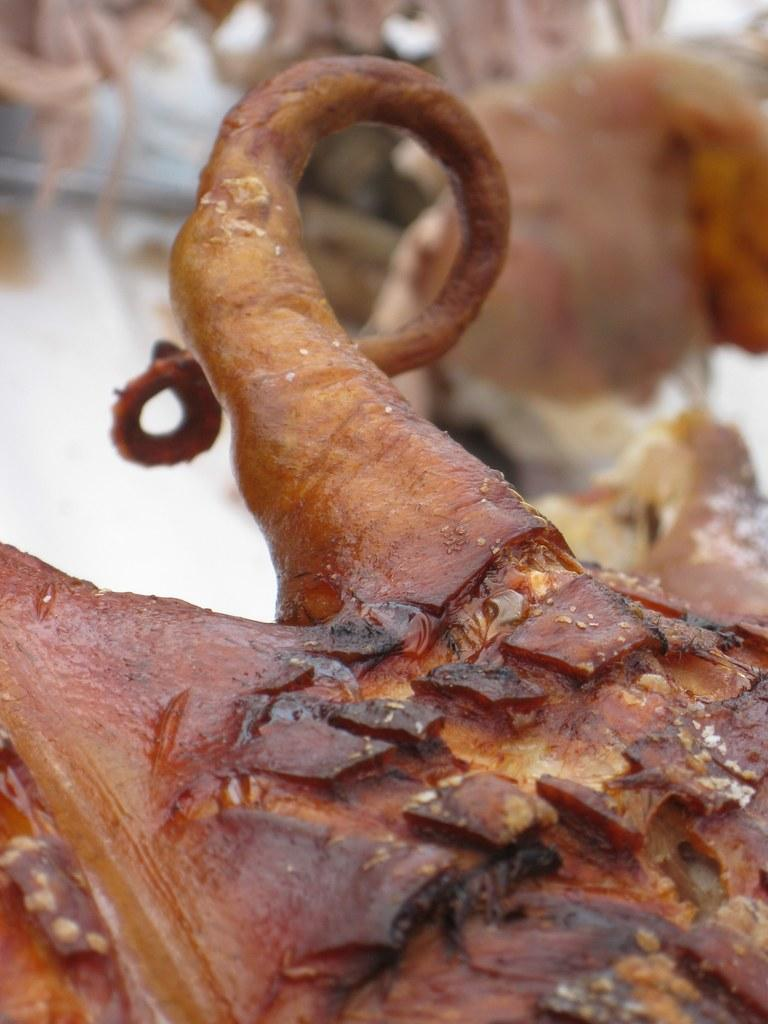What type of food item is visible in the image? The food item in the image has orange, brown, and black colors. Can you describe the color scheme of the food item? The food item has orange, brown, and black colors. What can be seen in the background of the image? There are other blurry items in the background of the image. What type of cloth is being used for the development of the food item in the image? There is no cloth or development process mentioned or visible in the image. 